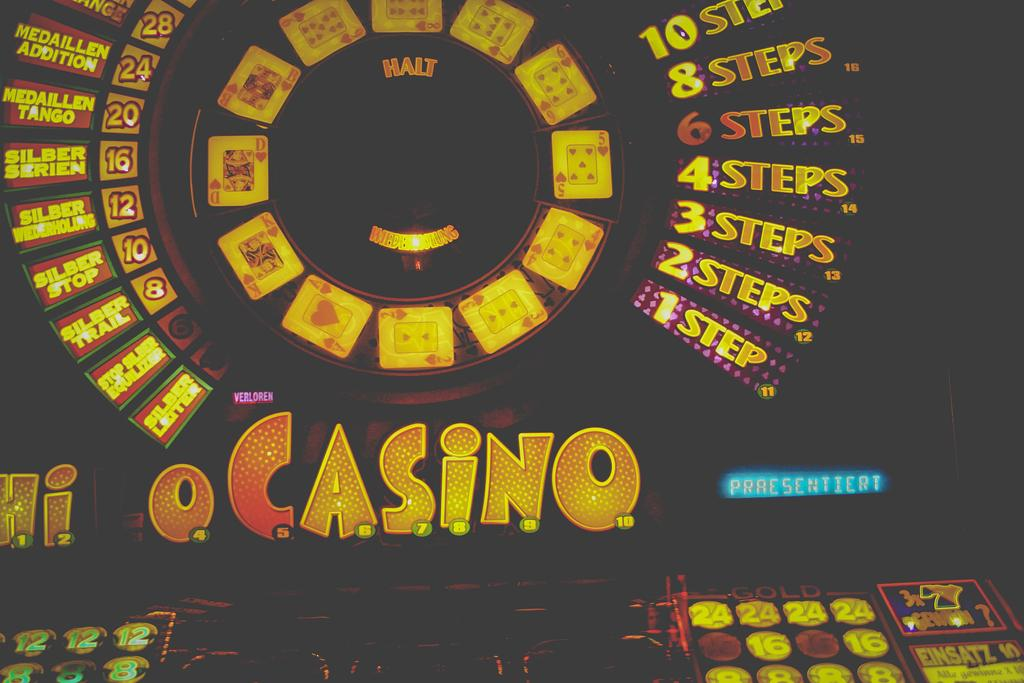<image>
Provide a brief description of the given image. a picture of a casino wheel diplaying different steps 